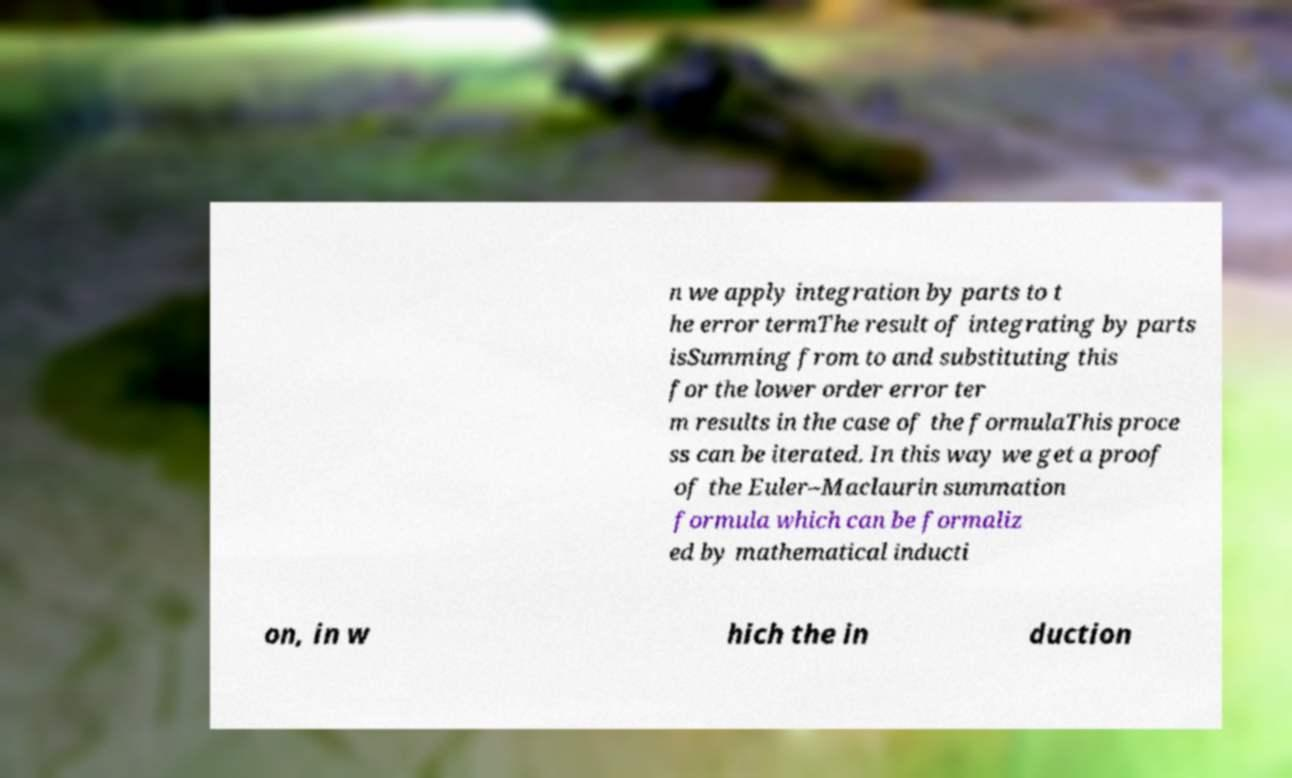Please identify and transcribe the text found in this image. n we apply integration by parts to t he error termThe result of integrating by parts isSumming from to and substituting this for the lower order error ter m results in the case of the formulaThis proce ss can be iterated. In this way we get a proof of the Euler–Maclaurin summation formula which can be formaliz ed by mathematical inducti on, in w hich the in duction 